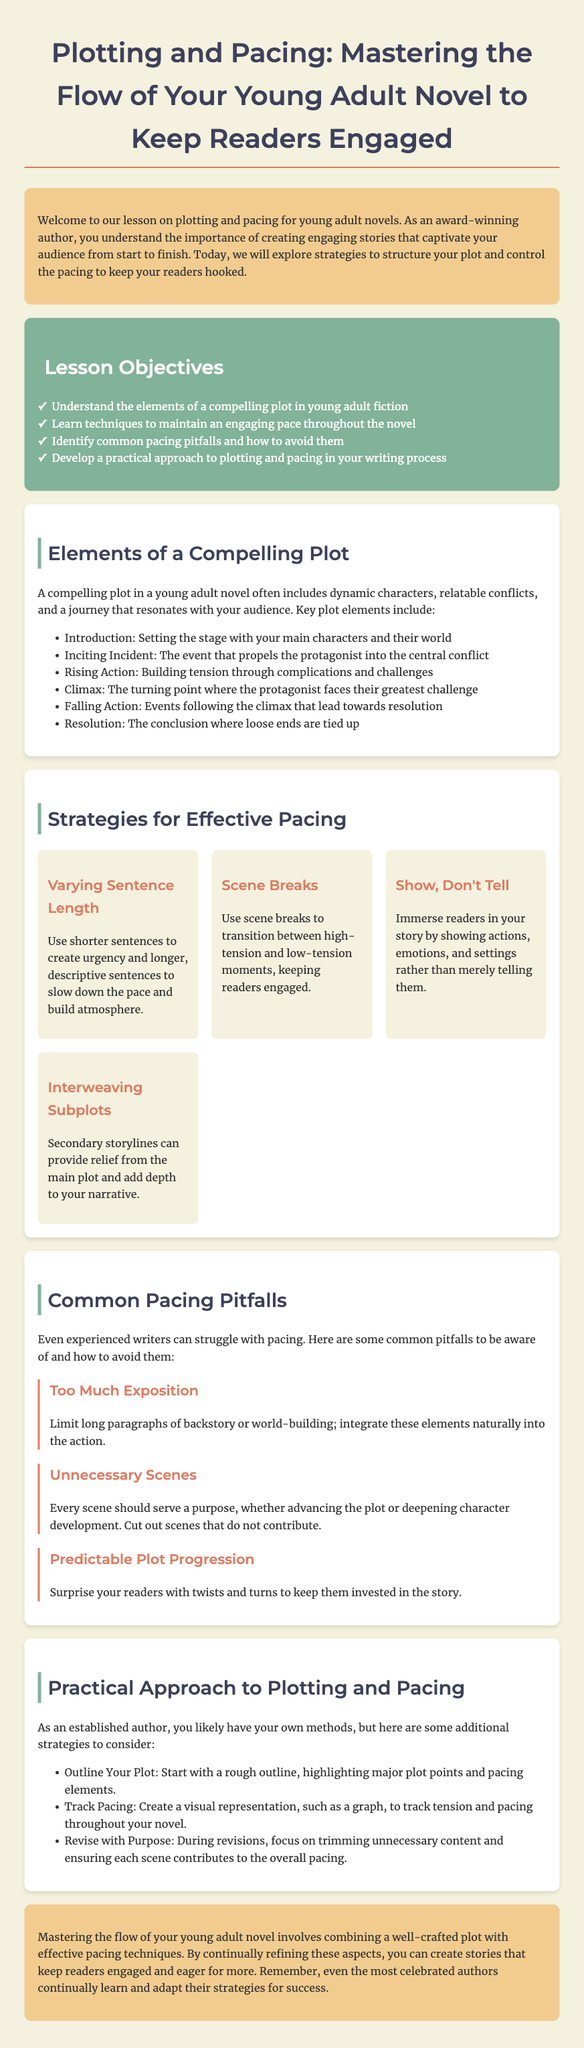What are the elements of a compelling plot? The document lists key plot elements essential for young adult fiction.
Answer: Introduction, Inciting Incident, Rising Action, Climax, Falling Action, Resolution What is the first lesson objective? The first objective mentioned in the document focuses on the understanding of plot elements.
Answer: Understand the elements of a compelling plot in young adult fiction Name one strategy for effective pacing. The document provides various strategies for pacing in storytelling.
Answer: Varying Sentence Length What common pacing pitfall involves backstory? The document explains a specific pitfall related to excessive exposition in writing.
Answer: Too Much Exposition How many tips for effective pacing are provided? The document outlines a set of strategies, detailing the number of tips given.
Answer: Four What is the purpose of revisions according to the document? The lesson emphasizes the importance of revisions in the writing process regarding pacing.
Answer: Focus on trimming unnecessary content and ensuring each scene contributes to the overall pacing What is emphasized as crucial for engaging readers? The document's conclusion states a fundamental element for maintaining reader interest.
Answer: Mastering the flow of your young adult novel Which segment discusses interweaving secondary storylines? The document describes a strategy that involves integrating subplots to enhance the narrative.
Answer: Strategies for Effective Pacing 